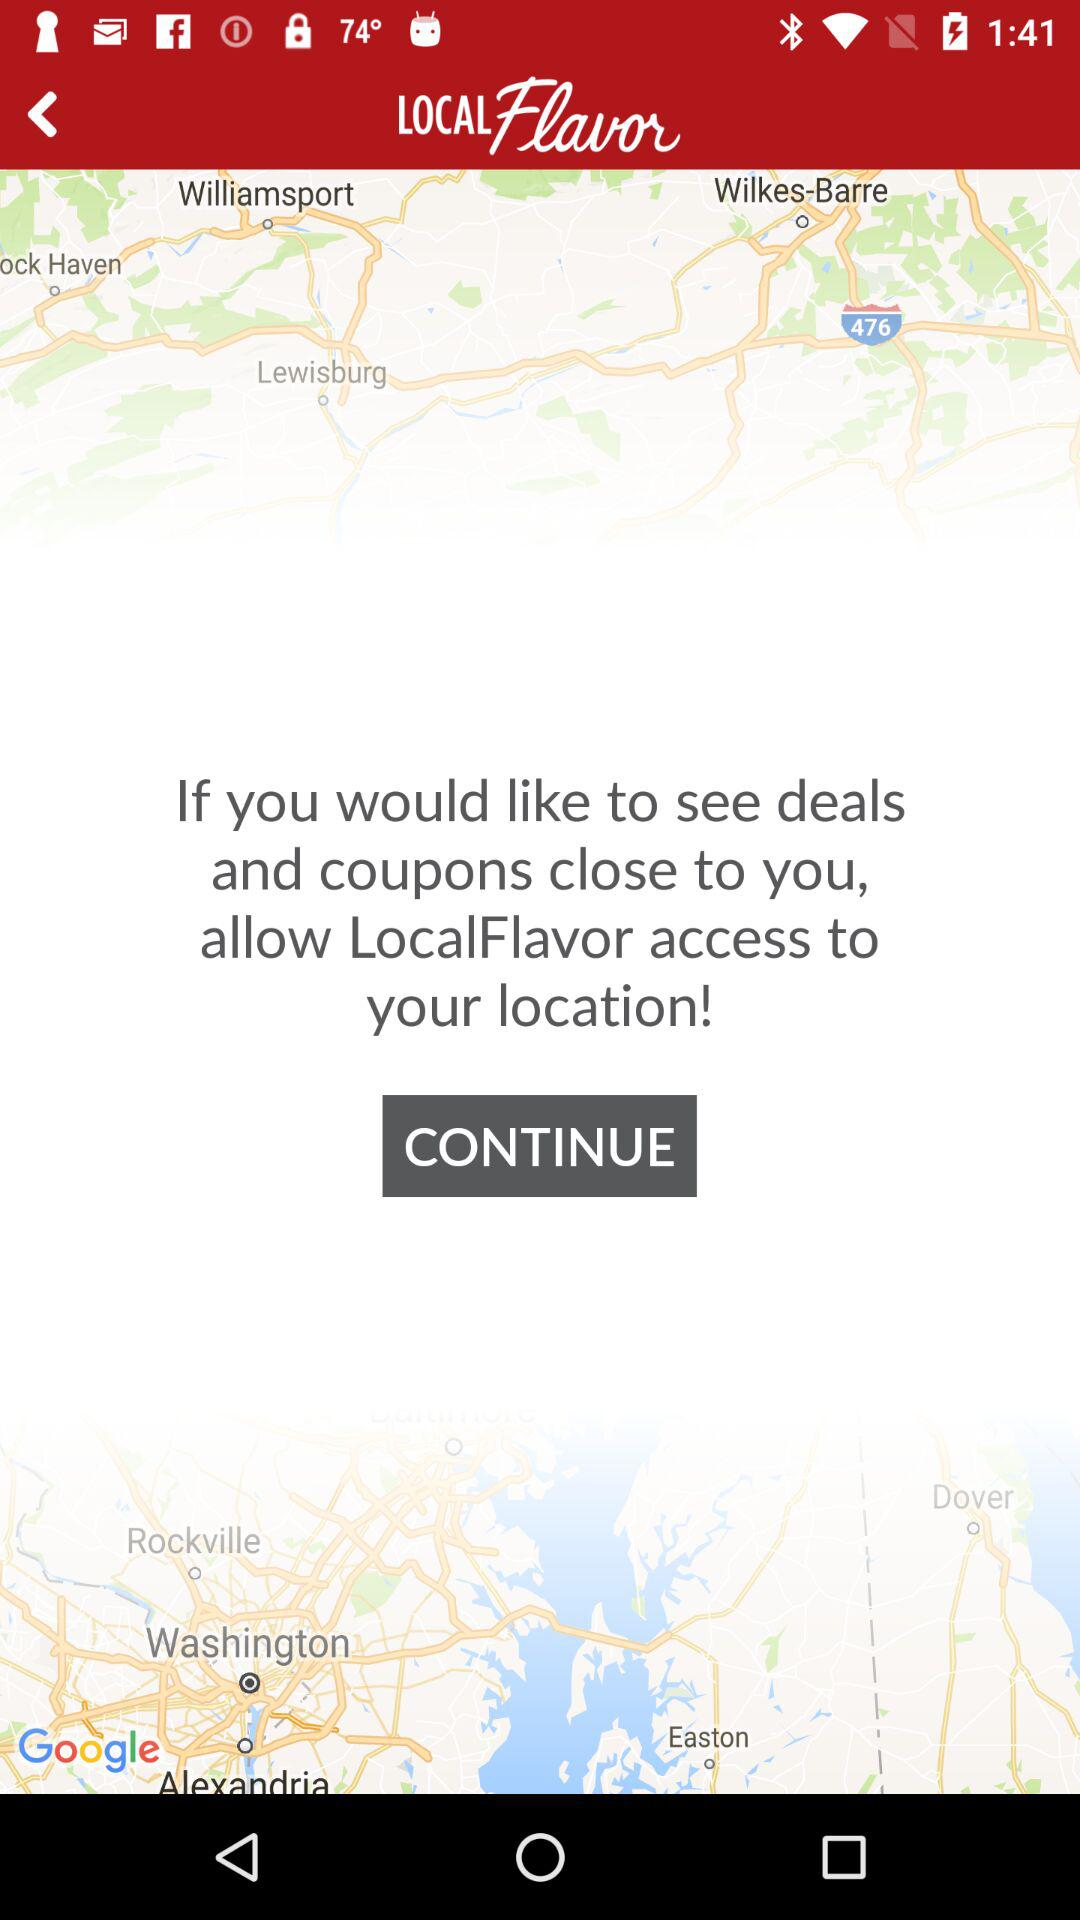What is the name of the application? The application name is "LOCALFlavor". 